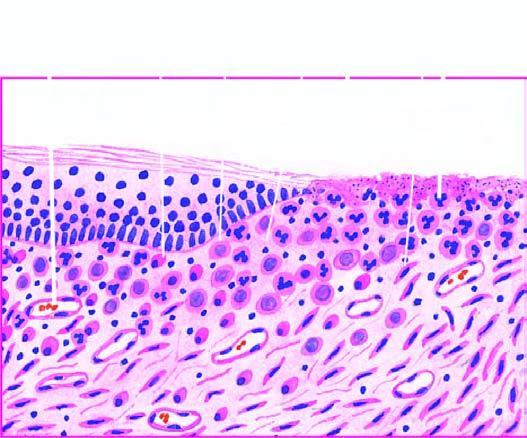what has inflammatory cell infiltrate, newly formed blood vessels and young fibrous tissue in loose matrix?
Answer the question using a single word or phrase. Active granulation tissue 